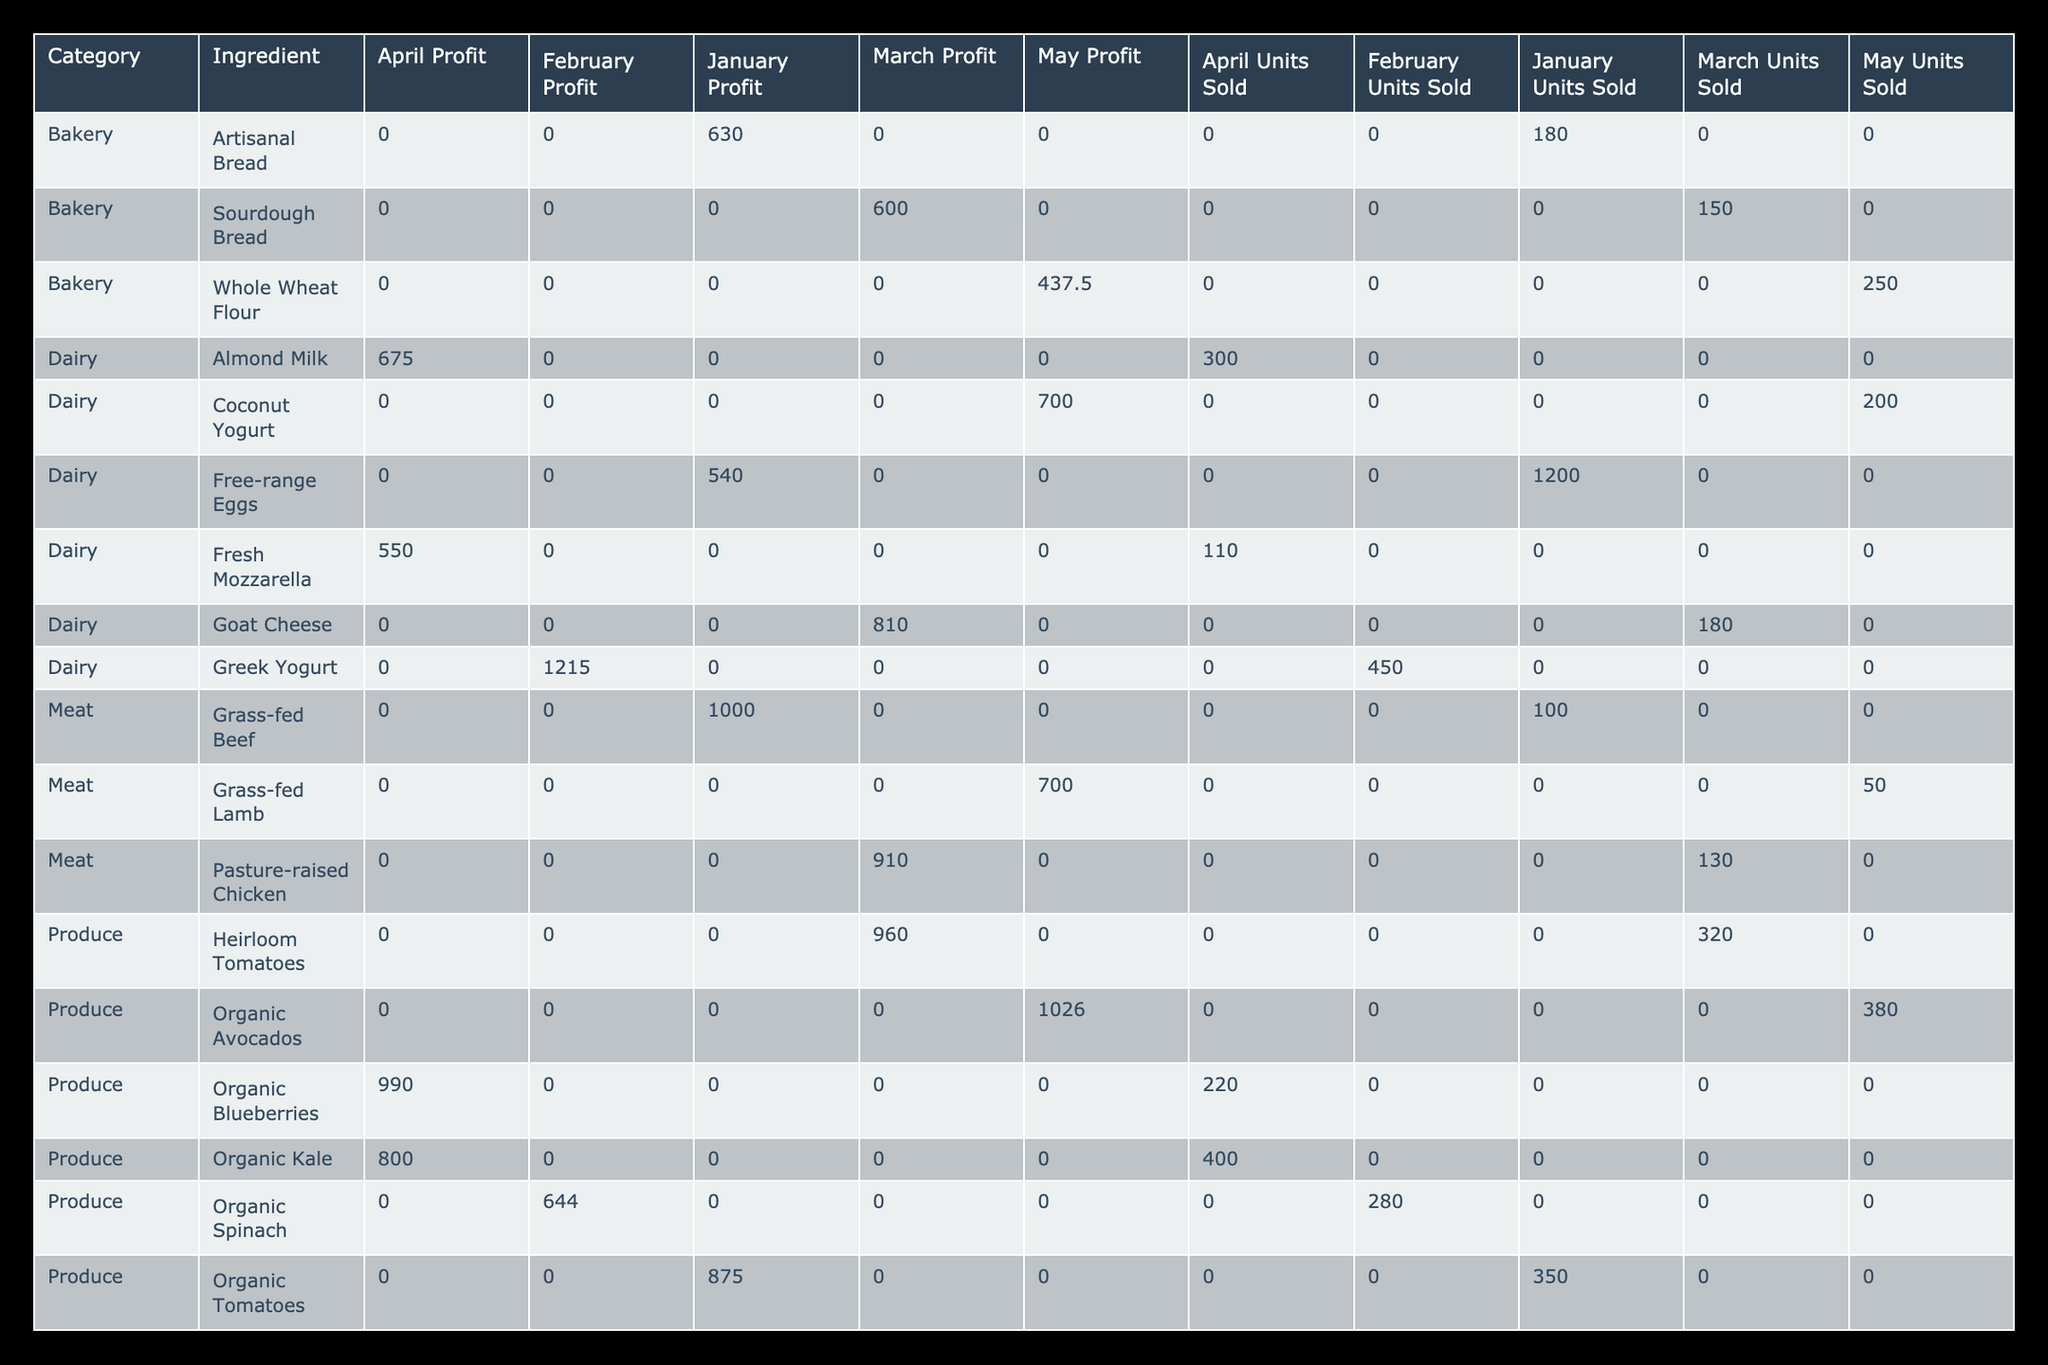What is the total profit generated from Organic Tomatoes in January? The profit from Organic Tomatoes is calculated by multiplying the profit per unit by the units sold. The profit per unit is ($4.00 - $1.50) = $2.50, and with 350 units sold, the total profit is $2.50 * 350 = $875.
Answer: 875 Which ingredient had the highest profit in March? In March, we sum the profits for each ingredient based on the profit calculations: Heirloom Tomatoes ($960), Goat Cheese ($900), Sourdough Bread ($675), Extra Virgin Olive Oil ($720), and Pasture-raised Chicken ($910). Heirloom Tomatoes produced the highest profit of $960.
Answer: Heirloom Tomatoes Is the selling price of Saffron higher than the selling price of Truffle Oil? The selling price of Saffron is $120.00 and for Truffle Oil it is $35.00. Since $120.00 is greater than $35.00, the statement is true.
Answer: Yes What is the average selling price of Dairy products across all months? The Dairy category includes Free-range Eggs ($0.75), Greek Yogurt ($4.50), Goat Cheese ($8.00), Almond Milk ($3.75), and Coconut Yogurt ($6.00). The total selling price is ($0.75 + $4.50 + $8.00 + $3.75 + $6.00) = $23.00. There are 5 Dairy products, thus the average selling price is $23.00 / 5 = $4.60.
Answer: 4.60 Which category generated the most profit in February? In February, we calculate total profits per category: Produce (Organic Spinach: $648, Total $648), Dairy (Greek Yogurt: $1530, Total $1530), Specialty (Gluten-free Pasta: $700 + Organic Honey: $330, Total $1030), and Seafood (Wild-caught Salmon: $900). The highest profit category in February is Dairy with $1530.
Answer: Dairy What is the total number of units sold for all Meat products combined? We add up the units sold for all Meat products: Grass-fed Beef (100), Pasture-raised Chicken (130), and Grass-fed Lamb (50). Total units sold is 100 + 130 + 50 = 280.
Answer: 280 Did Organic Avocados generate more profit in May than Organic Honey in February? For Organic Avocados in May: Selling price ($4.50) - Cost per unit ($1.80) = Profit per unit ($2.70). With 380 units sold: $2.70 * 380 = $1026. For Organic Honey in February: Selling price ($9.50) - Cost per unit ($4.00) = Profit per unit ($5.50). With 60 units sold: $5.50 * 60 = $330. Comparing the profits, Organic Avocados ($1026) generated more than Organic Honey ($330).
Answer: Yes What is the difference in profit between the ingredient with the highest and the lowest profit in January? In January, Truffle Oil's profit is ($35.00 - $15.00) * 25 = $500, while Free-range Eggs profit is ($0.75 - $0.30) * 1200 = $540. The highest profit is Free-range Eggs ($540) and the lowest is Truffle Oil ($500). The difference is $540 - $500 = $40.
Answer: 40 